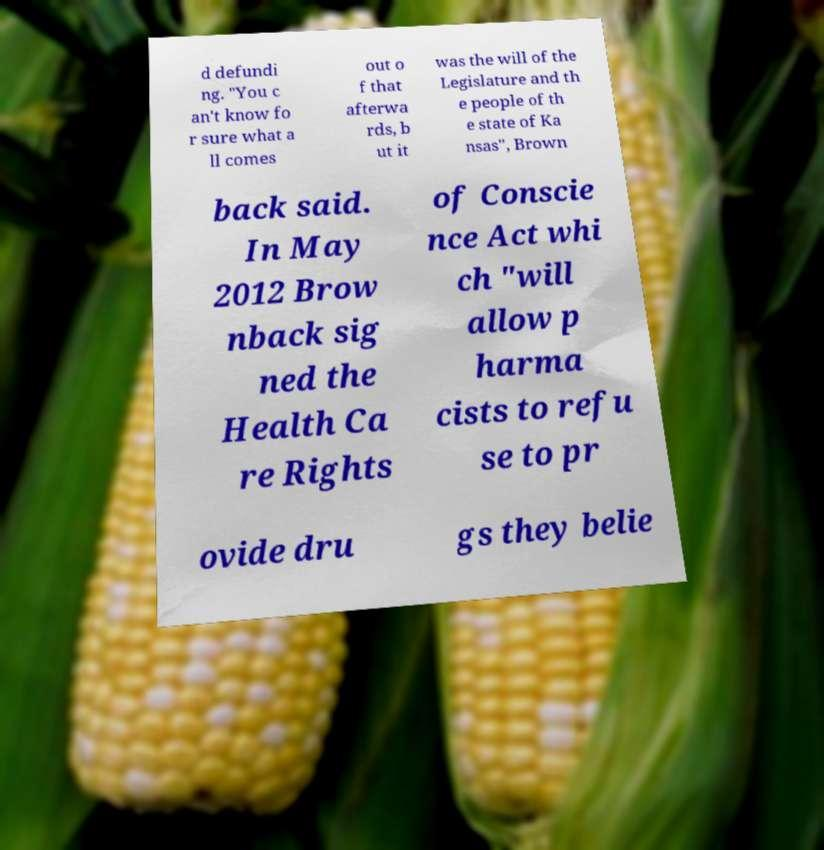For documentation purposes, I need the text within this image transcribed. Could you provide that? d defundi ng. "You c an't know fo r sure what a ll comes out o f that afterwa rds, b ut it was the will of the Legislature and th e people of th e state of Ka nsas", Brown back said. In May 2012 Brow nback sig ned the Health Ca re Rights of Conscie nce Act whi ch "will allow p harma cists to refu se to pr ovide dru gs they belie 